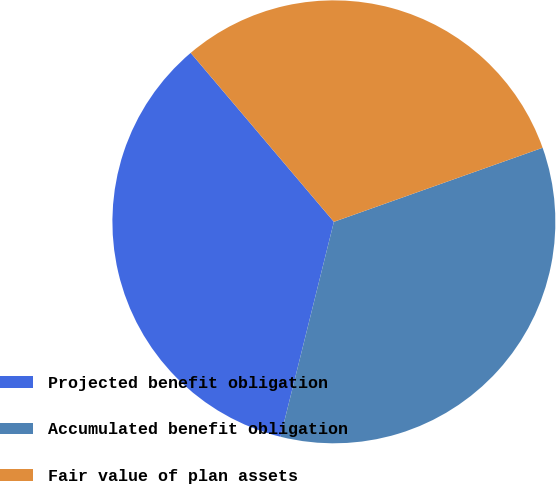Convert chart to OTSL. <chart><loc_0><loc_0><loc_500><loc_500><pie_chart><fcel>Projected benefit obligation<fcel>Accumulated benefit obligation<fcel>Fair value of plan assets<nl><fcel>34.93%<fcel>34.3%<fcel>30.76%<nl></chart> 